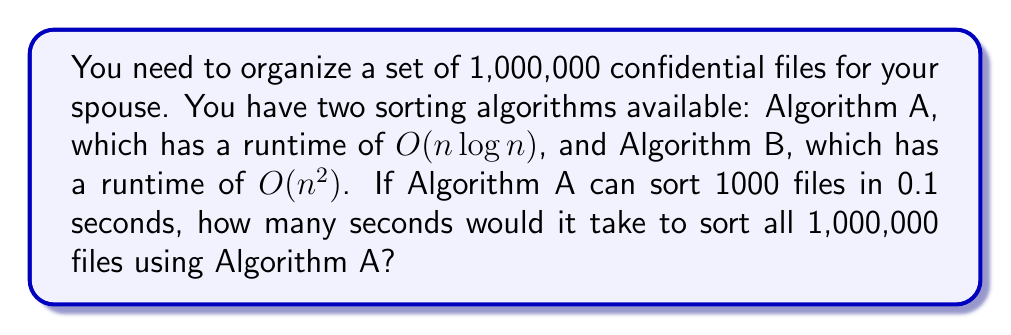Help me with this question. Let's approach this step-by-step:

1) First, we need to understand the growth rate of Algorithm A, which is $O(n \log n)$.

2) We're given that Algorithm A can sort 1000 files in 0.1 seconds. Let's call this time $t_1$:

   $t_1 = 0.1$ seconds for $n_1 = 1000$ files

3) We want to find $t_2$ for $n_2 = 1,000,000$ files.

4) For an $O(n \log n)$ algorithm, the relationship between times and number of elements is:

   $\frac{t_2}{t_1} = \frac{n_2 \log n_2}{n_1 \log n_1}$

5) Substituting our known values:

   $\frac{t_2}{0.1} = \frac{1,000,000 \log 1,000,000}{1000 \log 1000}$

6) Simplify:
   
   $\frac{t_2}{0.1} = \frac{1,000,000 \cdot 6}{1000 \cdot 3} = 2000$

7) Solve for $t_2$:

   $t_2 = 0.1 \cdot 2000 = 200$ seconds

Therefore, it would take 200 seconds to sort 1,000,000 files using Algorithm A.
Answer: 200 seconds 